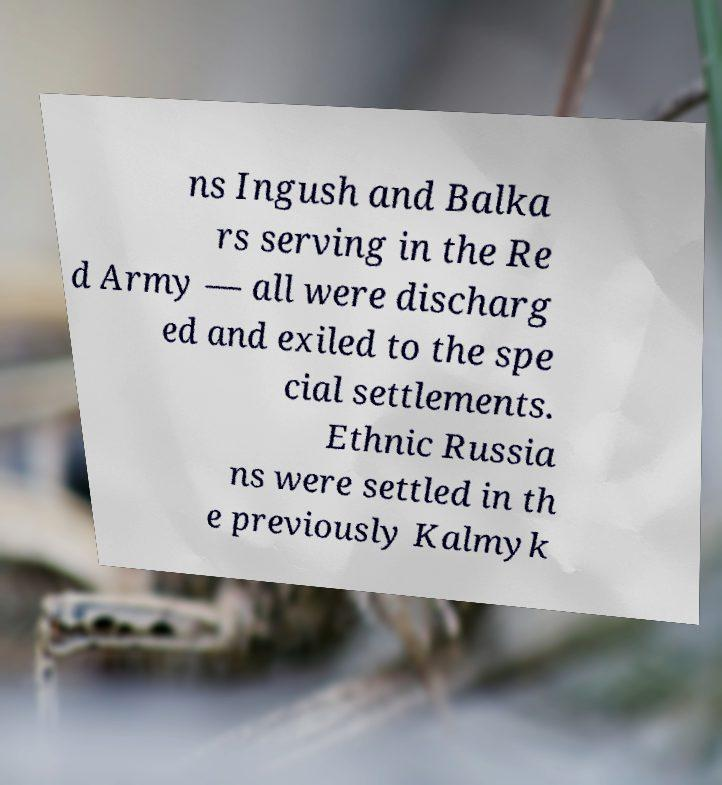Can you read and provide the text displayed in the image?This photo seems to have some interesting text. Can you extract and type it out for me? ns Ingush and Balka rs serving in the Re d Army — all were discharg ed and exiled to the spe cial settlements. Ethnic Russia ns were settled in th e previously Kalmyk 